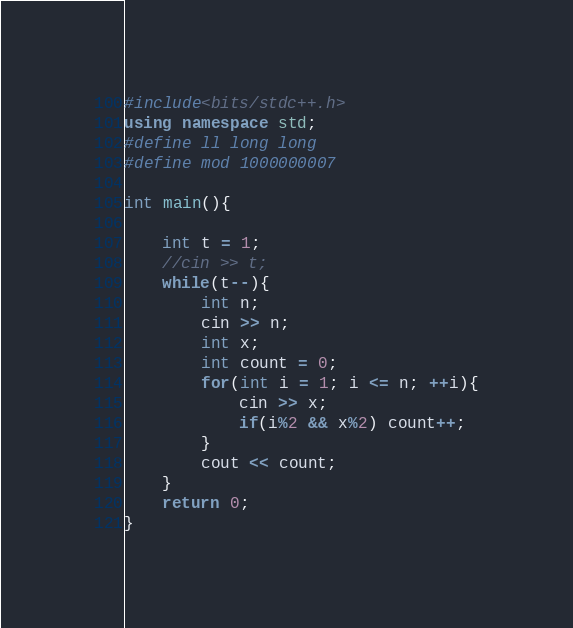<code> <loc_0><loc_0><loc_500><loc_500><_C++_>#include<bits/stdc++.h>
using namespace std;
#define ll long long
#define mod 1000000007

int main(){

	int t = 1;
	//cin >> t;
	while(t--){
		int n;
		cin >> n;
		int x;
		int count = 0;
		for(int i = 1; i <= n; ++i){
			cin >> x;
			if(i%2 && x%2) count++;
		}
		cout << count;
	}
	return 0;
}</code> 